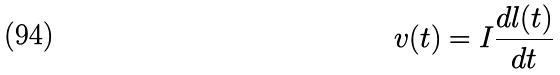<formula> <loc_0><loc_0><loc_500><loc_500>v ( t ) = I \frac { d l ( t ) } { d t }</formula> 